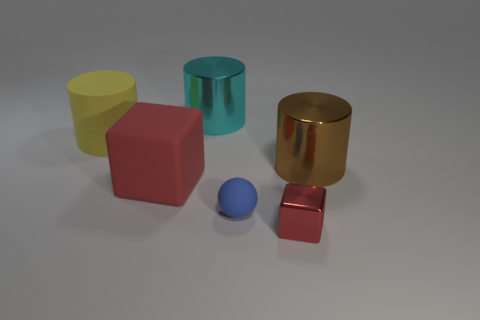Does the small metallic thing have the same color as the big cube?
Your response must be concise. Yes. There is a shiny cylinder that is in front of the large yellow matte cylinder; does it have the same color as the large metal thing behind the yellow rubber cylinder?
Your answer should be very brief. No. Is the number of small blue balls in front of the blue matte sphere less than the number of balls that are behind the metal cube?
Provide a succinct answer. Yes. Is there anything else that is the same shape as the small red metallic thing?
Make the answer very short. Yes. What is the color of the other metal thing that is the same shape as the big brown shiny thing?
Provide a short and direct response. Cyan. There is a big brown object; is it the same shape as the small matte object right of the big cyan cylinder?
Offer a very short reply. No. How many things are either red objects to the left of the rubber ball or things to the left of the large block?
Your answer should be compact. 2. What is the large cyan cylinder made of?
Your answer should be very brief. Metal. How many other objects are the same size as the brown metal cylinder?
Offer a terse response. 3. There is a cylinder that is in front of the large yellow matte cylinder; how big is it?
Make the answer very short. Large. 